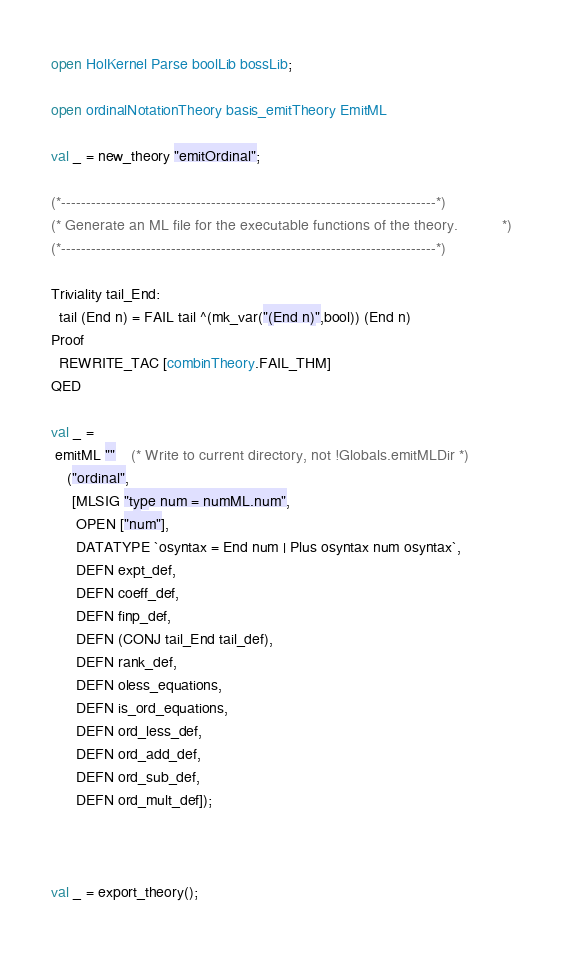Convert code to text. <code><loc_0><loc_0><loc_500><loc_500><_SML_>open HolKernel Parse boolLib bossLib;

open ordinalNotationTheory basis_emitTheory EmitML

val _ = new_theory "emitOrdinal";

(*---------------------------------------------------------------------------*)
(* Generate an ML file for the executable functions of the theory.           *)
(*---------------------------------------------------------------------------*)

Triviality tail_End:
  tail (End n) = FAIL tail ^(mk_var("(End n)",bool)) (End n)
Proof
  REWRITE_TAC [combinTheory.FAIL_THM]
QED

val _ =
 emitML ""    (* Write to current directory, not !Globals.emitMLDir *)
    ("ordinal",
     [MLSIG "type num = numML.num",
      OPEN ["num"],
      DATATYPE `osyntax = End num | Plus osyntax num osyntax`,
      DEFN expt_def,
      DEFN coeff_def,
      DEFN finp_def,
      DEFN (CONJ tail_End tail_def),
      DEFN rank_def,
      DEFN oless_equations,
      DEFN is_ord_equations,
      DEFN ord_less_def,
      DEFN ord_add_def,
      DEFN ord_sub_def,
      DEFN ord_mult_def]);



val _ = export_theory();
</code> 